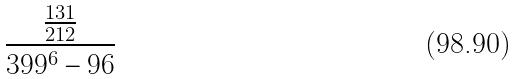<formula> <loc_0><loc_0><loc_500><loc_500>\frac { \frac { 1 3 1 } { 2 1 2 } } { 3 9 9 ^ { 6 } - 9 6 }</formula> 